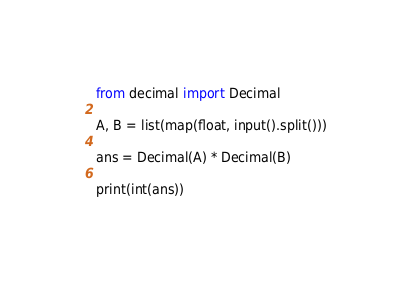<code> <loc_0><loc_0><loc_500><loc_500><_Python_>from decimal import Decimal

A, B = list(map(float, input().split()))

ans = Decimal(A) * Decimal(B)

print(int(ans))</code> 